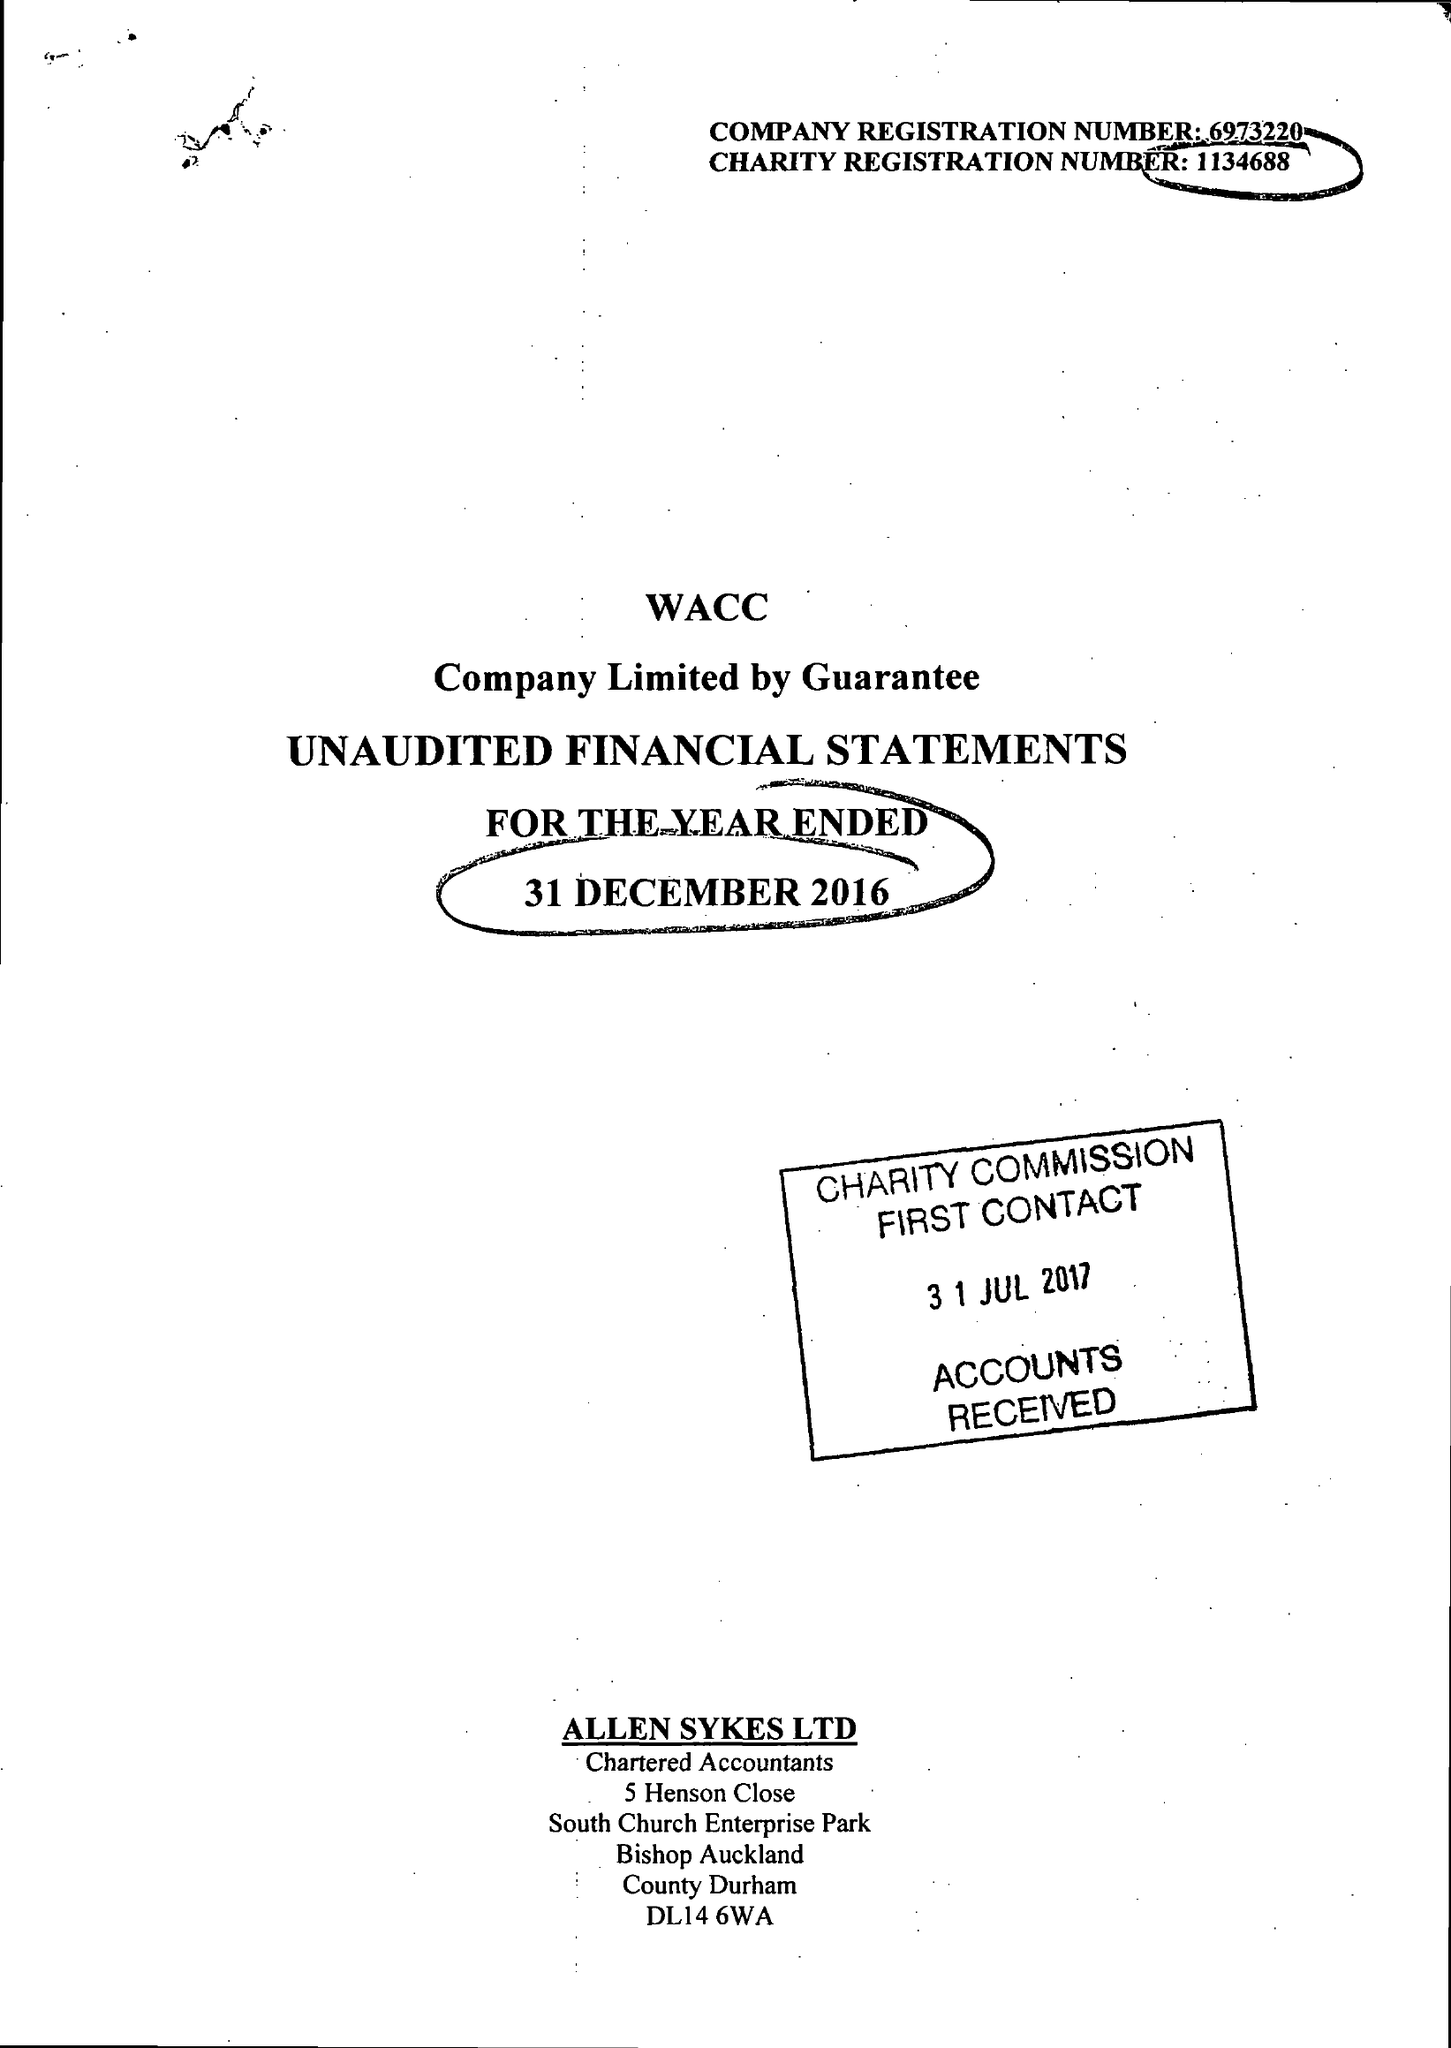What is the value for the charity_number?
Answer the question using a single word or phrase. 1134688 